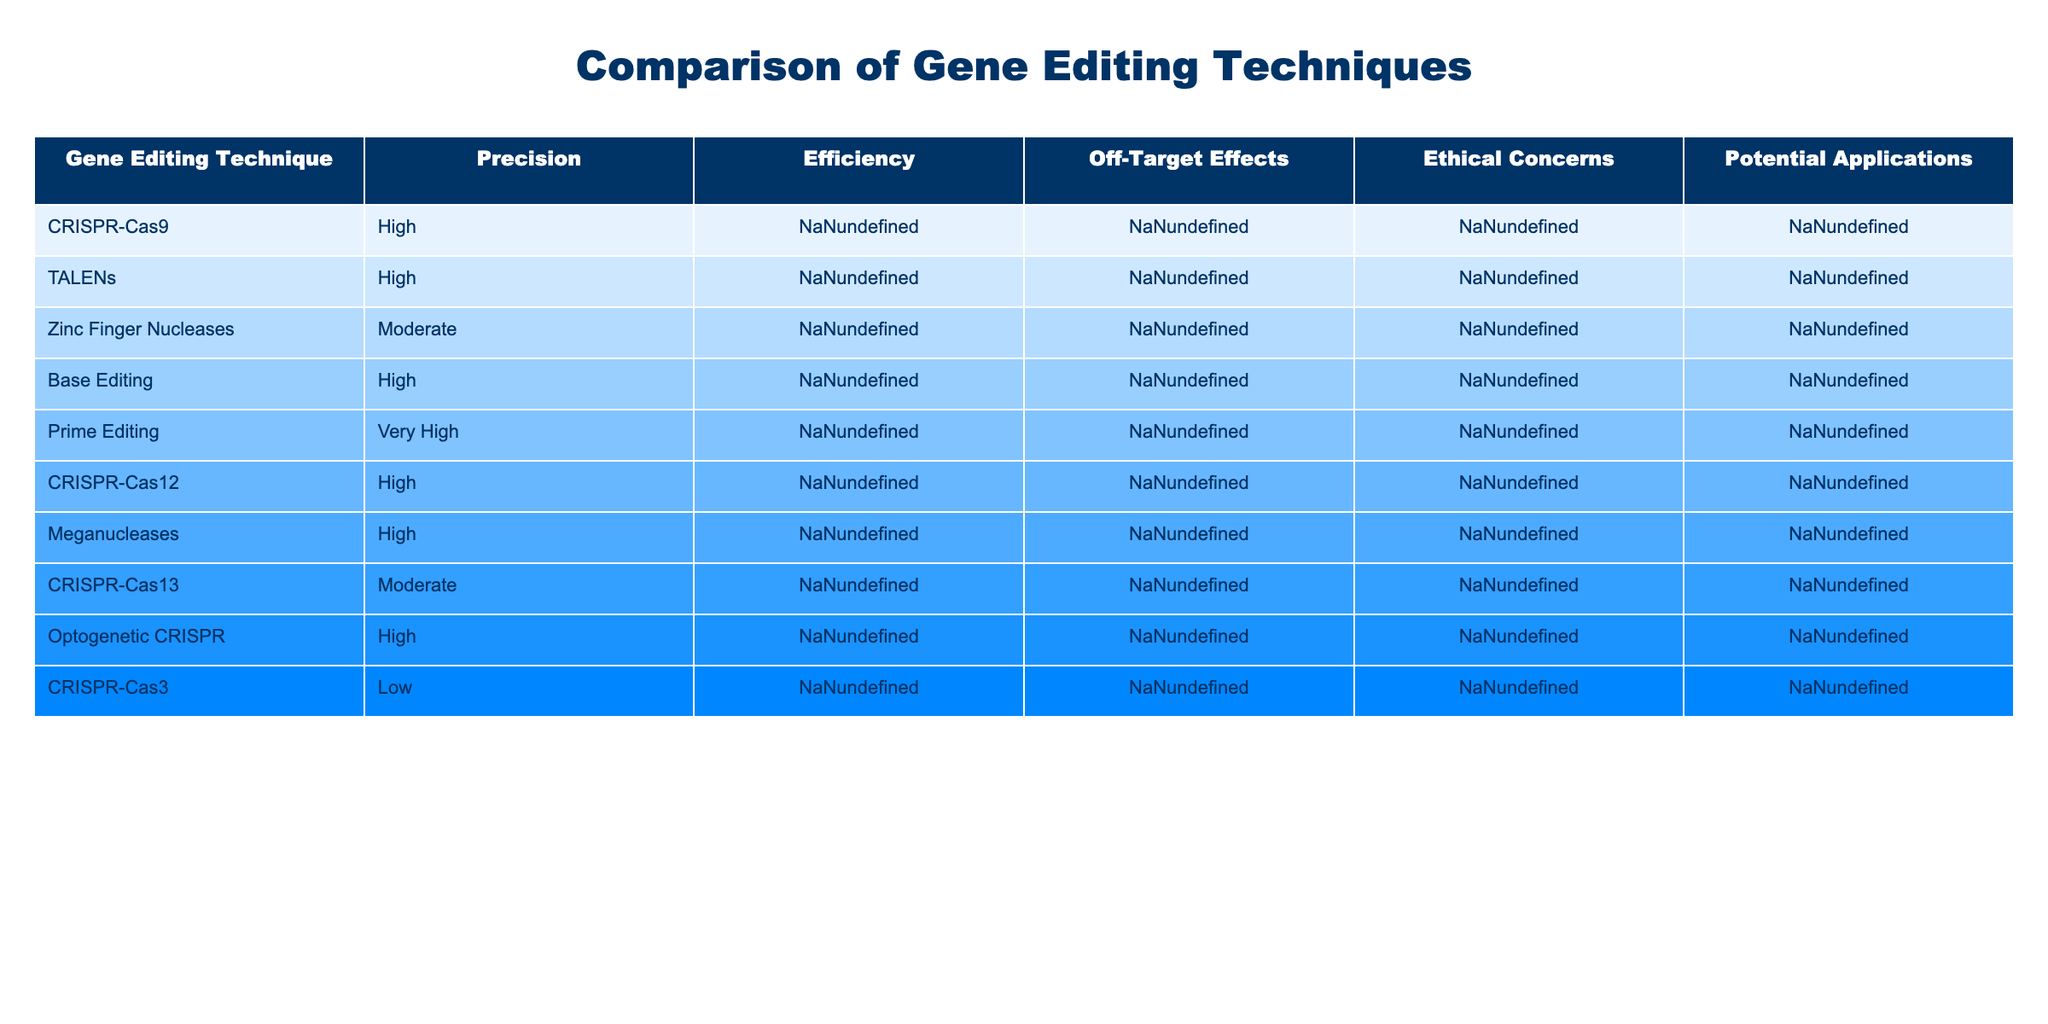What gene editing technique has the highest precision? By looking at the Precision column, CRISPR-Cas12 and Prime Editing both have "Very High" precision, which is the highest level noted in the table.
Answer: CRISPR-Cas12 and Prime Editing Which gene editing technique has the lowest off-target effects? The Off-Target Effects column shows that Meganucleases have "Very Low" off-target effects, which is the lowest rating in the table.
Answer: Meganucleases What is the potential application of Base Editing? The Potential Applications column specifies that Base Editing is utilized for correcting genetic disorders.
Answer: Genetic disorder correction Is there a technique with moderate efficiency and low off-target effects? The table shows that Zinc Finger Nucleases are noted for having "Moderate" efficiency and "Low" off-target effects.
Answer: Yes, Zinc Finger Nucleases Which gene editing technique has biosecurity risks as an ethical concern? The Ethical Concerns column identifies CRISPR-Cas12 as having biosecurity risks associated with it.
Answer: CRISPR-Cas12 What is the average efficiency of the gene editing techniques listed? Adding the efficiencies: High (3), Moderate (3), Very High (1), Low (1) gives a total of 13. Dividing by the number of techniques (10) results in an average efficiency rating of approximately 1.3. The rating scheme can be roughly assigned values, with High (3), Moderate (2), Low (1), and Very High (4) leading to a final average of 2.1, which is leaning towards the "High" category when interpreted.
Answer: High Which gene editing technique addresses germline editing concerns? In the Ethical Concerns section, it notes that CRISPR-Cas9 faces germline editing concerns.
Answer: CRISPR-Cas9 How many techniques have high efficiency? The Efficiency column shows that CRISPR-Cas9, CRISPR-Cas12, and Optogenetic CRISPR are all labeled as "High"; therefore, there are 4 techniques total with High efficiency.
Answer: 4 Which gene editing techniques have ethical concerns related to animal testing? The Ethical Concerns section specifies that Optogenetic CRISPR raises ethical issues relating to animal testing.
Answer: Optogenetic CRISPR Is there a gene editing technique that excels in precision but has moderate efficiency? By analyzing both Precision and Efficiency columns, Prime Editing stands out with "Very High" precision but only "Moderate" efficiency which fits the criteria.
Answer: No 